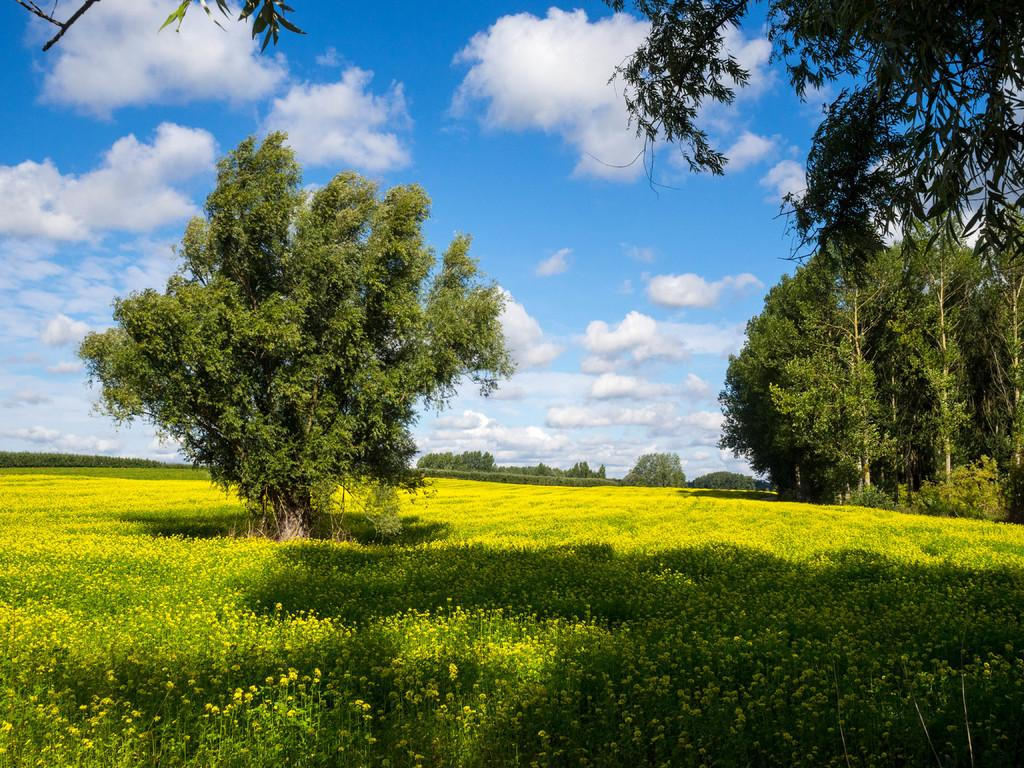What type of vegetation is present on the ground in the image? There are plants on the ground in the image. What other type of vegetation can be seen in the image? There are trees in the image. What can be seen in the sky in the background of the image? There are clouds visible in the sky in the background of the image. How many snakes are slithering through the plants in the image? There are no snakes present in the image; it only features plants and trees. What type of harbor can be seen in the image? There is no harbor present in the image; it is a natural scene with plants, trees, and clouds. 